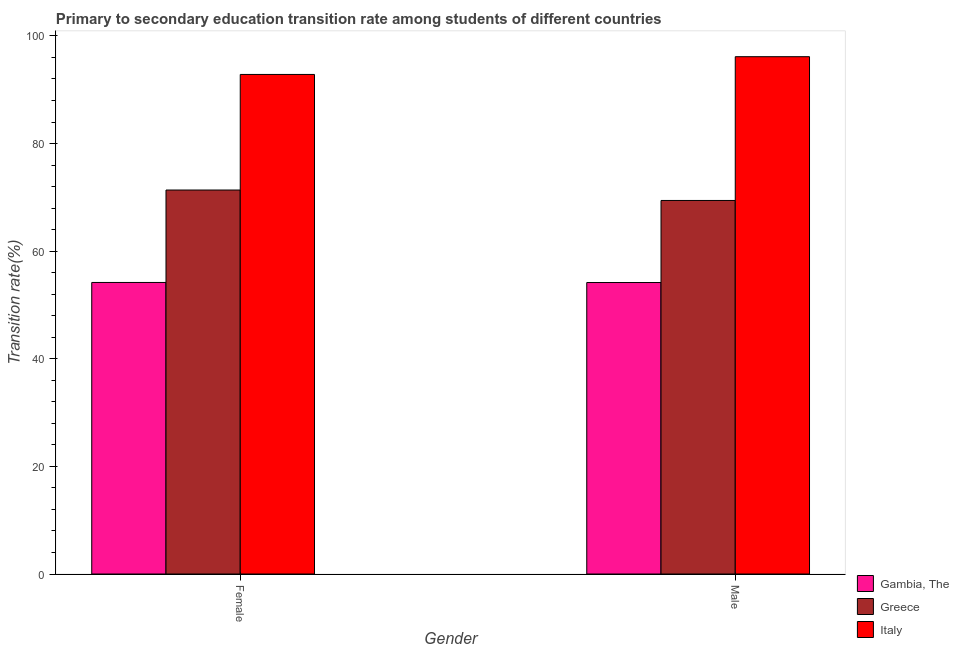How many groups of bars are there?
Provide a succinct answer. 2. Are the number of bars per tick equal to the number of legend labels?
Give a very brief answer. Yes. How many bars are there on the 1st tick from the left?
Give a very brief answer. 3. How many bars are there on the 2nd tick from the right?
Ensure brevity in your answer.  3. What is the transition rate among female students in Greece?
Give a very brief answer. 71.36. Across all countries, what is the maximum transition rate among male students?
Offer a very short reply. 96.14. Across all countries, what is the minimum transition rate among male students?
Ensure brevity in your answer.  54.17. In which country was the transition rate among male students minimum?
Make the answer very short. Gambia, The. What is the total transition rate among male students in the graph?
Provide a short and direct response. 219.74. What is the difference between the transition rate among female students in Greece and that in Italy?
Your response must be concise. -21.48. What is the difference between the transition rate among female students in Gambia, The and the transition rate among male students in Greece?
Ensure brevity in your answer.  -15.24. What is the average transition rate among male students per country?
Ensure brevity in your answer.  73.25. What is the difference between the transition rate among male students and transition rate among female students in Italy?
Keep it short and to the point. 3.3. What is the ratio of the transition rate among female students in Italy to that in Greece?
Your answer should be compact. 1.3. In how many countries, is the transition rate among female students greater than the average transition rate among female students taken over all countries?
Your answer should be compact. 1. What does the 3rd bar from the left in Male represents?
Give a very brief answer. Italy. What does the 3rd bar from the right in Male represents?
Offer a very short reply. Gambia, The. How many bars are there?
Provide a succinct answer. 6. How many countries are there in the graph?
Keep it short and to the point. 3. Does the graph contain any zero values?
Keep it short and to the point. No. What is the title of the graph?
Your response must be concise. Primary to secondary education transition rate among students of different countries. Does "Turkmenistan" appear as one of the legend labels in the graph?
Keep it short and to the point. No. What is the label or title of the Y-axis?
Give a very brief answer. Transition rate(%). What is the Transition rate(%) in Gambia, The in Female?
Provide a succinct answer. 54.18. What is the Transition rate(%) in Greece in Female?
Your answer should be compact. 71.36. What is the Transition rate(%) in Italy in Female?
Make the answer very short. 92.84. What is the Transition rate(%) in Gambia, The in Male?
Give a very brief answer. 54.17. What is the Transition rate(%) in Greece in Male?
Keep it short and to the point. 69.42. What is the Transition rate(%) in Italy in Male?
Make the answer very short. 96.14. Across all Gender, what is the maximum Transition rate(%) of Gambia, The?
Your response must be concise. 54.18. Across all Gender, what is the maximum Transition rate(%) in Greece?
Provide a short and direct response. 71.36. Across all Gender, what is the maximum Transition rate(%) of Italy?
Ensure brevity in your answer.  96.14. Across all Gender, what is the minimum Transition rate(%) in Gambia, The?
Your response must be concise. 54.17. Across all Gender, what is the minimum Transition rate(%) of Greece?
Give a very brief answer. 69.42. Across all Gender, what is the minimum Transition rate(%) in Italy?
Make the answer very short. 92.84. What is the total Transition rate(%) in Gambia, The in the graph?
Your response must be concise. 108.36. What is the total Transition rate(%) of Greece in the graph?
Give a very brief answer. 140.79. What is the total Transition rate(%) in Italy in the graph?
Offer a terse response. 188.98. What is the difference between the Transition rate(%) of Gambia, The in Female and that in Male?
Offer a very short reply. 0.01. What is the difference between the Transition rate(%) in Greece in Female and that in Male?
Ensure brevity in your answer.  1.94. What is the difference between the Transition rate(%) of Italy in Female and that in Male?
Your answer should be very brief. -3.3. What is the difference between the Transition rate(%) of Gambia, The in Female and the Transition rate(%) of Greece in Male?
Provide a short and direct response. -15.24. What is the difference between the Transition rate(%) in Gambia, The in Female and the Transition rate(%) in Italy in Male?
Your response must be concise. -41.96. What is the difference between the Transition rate(%) in Greece in Female and the Transition rate(%) in Italy in Male?
Your response must be concise. -24.78. What is the average Transition rate(%) in Gambia, The per Gender?
Your answer should be compact. 54.18. What is the average Transition rate(%) of Greece per Gender?
Your answer should be very brief. 70.39. What is the average Transition rate(%) in Italy per Gender?
Your answer should be compact. 94.49. What is the difference between the Transition rate(%) of Gambia, The and Transition rate(%) of Greece in Female?
Ensure brevity in your answer.  -17.18. What is the difference between the Transition rate(%) in Gambia, The and Transition rate(%) in Italy in Female?
Keep it short and to the point. -38.66. What is the difference between the Transition rate(%) in Greece and Transition rate(%) in Italy in Female?
Make the answer very short. -21.48. What is the difference between the Transition rate(%) of Gambia, The and Transition rate(%) of Greece in Male?
Offer a terse response. -15.25. What is the difference between the Transition rate(%) in Gambia, The and Transition rate(%) in Italy in Male?
Your answer should be compact. -41.97. What is the difference between the Transition rate(%) in Greece and Transition rate(%) in Italy in Male?
Offer a terse response. -26.72. What is the ratio of the Transition rate(%) in Greece in Female to that in Male?
Provide a succinct answer. 1.03. What is the ratio of the Transition rate(%) of Italy in Female to that in Male?
Offer a very short reply. 0.97. What is the difference between the highest and the second highest Transition rate(%) of Gambia, The?
Your answer should be compact. 0.01. What is the difference between the highest and the second highest Transition rate(%) of Greece?
Offer a terse response. 1.94. What is the difference between the highest and the second highest Transition rate(%) of Italy?
Your answer should be compact. 3.3. What is the difference between the highest and the lowest Transition rate(%) of Gambia, The?
Give a very brief answer. 0.01. What is the difference between the highest and the lowest Transition rate(%) in Greece?
Give a very brief answer. 1.94. What is the difference between the highest and the lowest Transition rate(%) of Italy?
Give a very brief answer. 3.3. 